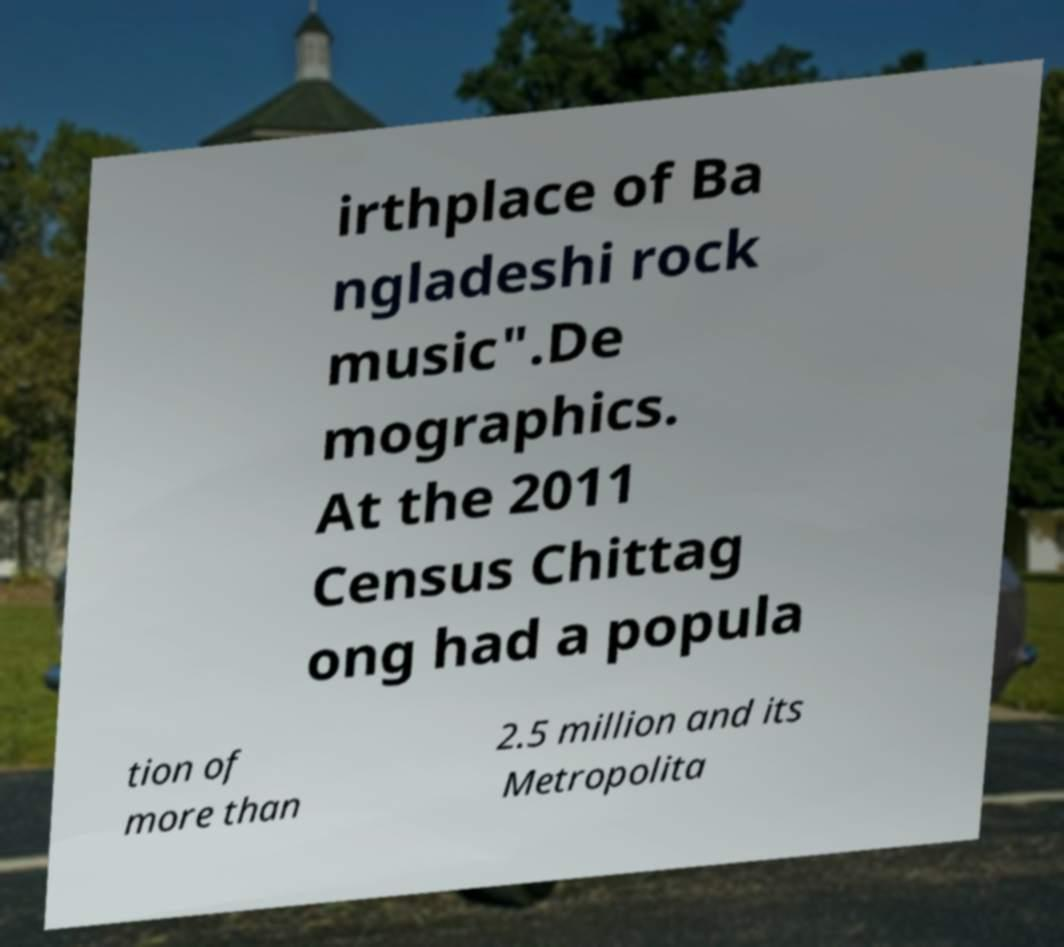There's text embedded in this image that I need extracted. Can you transcribe it verbatim? irthplace of Ba ngladeshi rock music".De mographics. At the 2011 Census Chittag ong had a popula tion of more than 2.5 million and its Metropolita 